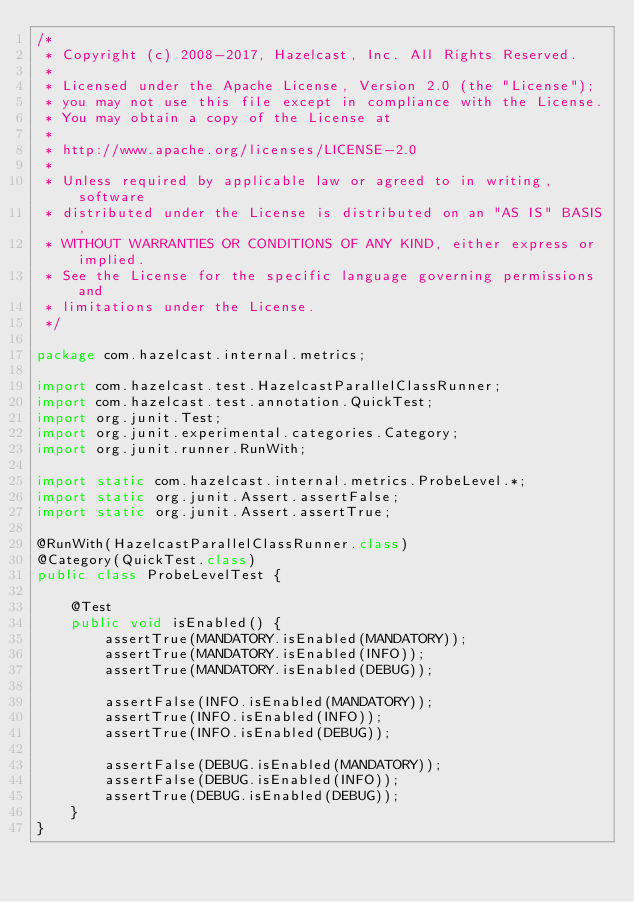Convert code to text. <code><loc_0><loc_0><loc_500><loc_500><_Java_>/*
 * Copyright (c) 2008-2017, Hazelcast, Inc. All Rights Reserved.
 *
 * Licensed under the Apache License, Version 2.0 (the "License");
 * you may not use this file except in compliance with the License.
 * You may obtain a copy of the License at
 *
 * http://www.apache.org/licenses/LICENSE-2.0
 *
 * Unless required by applicable law or agreed to in writing, software
 * distributed under the License is distributed on an "AS IS" BASIS,
 * WITHOUT WARRANTIES OR CONDITIONS OF ANY KIND, either express or implied.
 * See the License for the specific language governing permissions and
 * limitations under the License.
 */

package com.hazelcast.internal.metrics;

import com.hazelcast.test.HazelcastParallelClassRunner;
import com.hazelcast.test.annotation.QuickTest;
import org.junit.Test;
import org.junit.experimental.categories.Category;
import org.junit.runner.RunWith;

import static com.hazelcast.internal.metrics.ProbeLevel.*;
import static org.junit.Assert.assertFalse;
import static org.junit.Assert.assertTrue;

@RunWith(HazelcastParallelClassRunner.class)
@Category(QuickTest.class)
public class ProbeLevelTest {

    @Test
    public void isEnabled() {
        assertTrue(MANDATORY.isEnabled(MANDATORY));
        assertTrue(MANDATORY.isEnabled(INFO));
        assertTrue(MANDATORY.isEnabled(DEBUG));

        assertFalse(INFO.isEnabled(MANDATORY));
        assertTrue(INFO.isEnabled(INFO));
        assertTrue(INFO.isEnabled(DEBUG));

        assertFalse(DEBUG.isEnabled(MANDATORY));
        assertFalse(DEBUG.isEnabled(INFO));
        assertTrue(DEBUG.isEnabled(DEBUG));
    }
}
</code> 